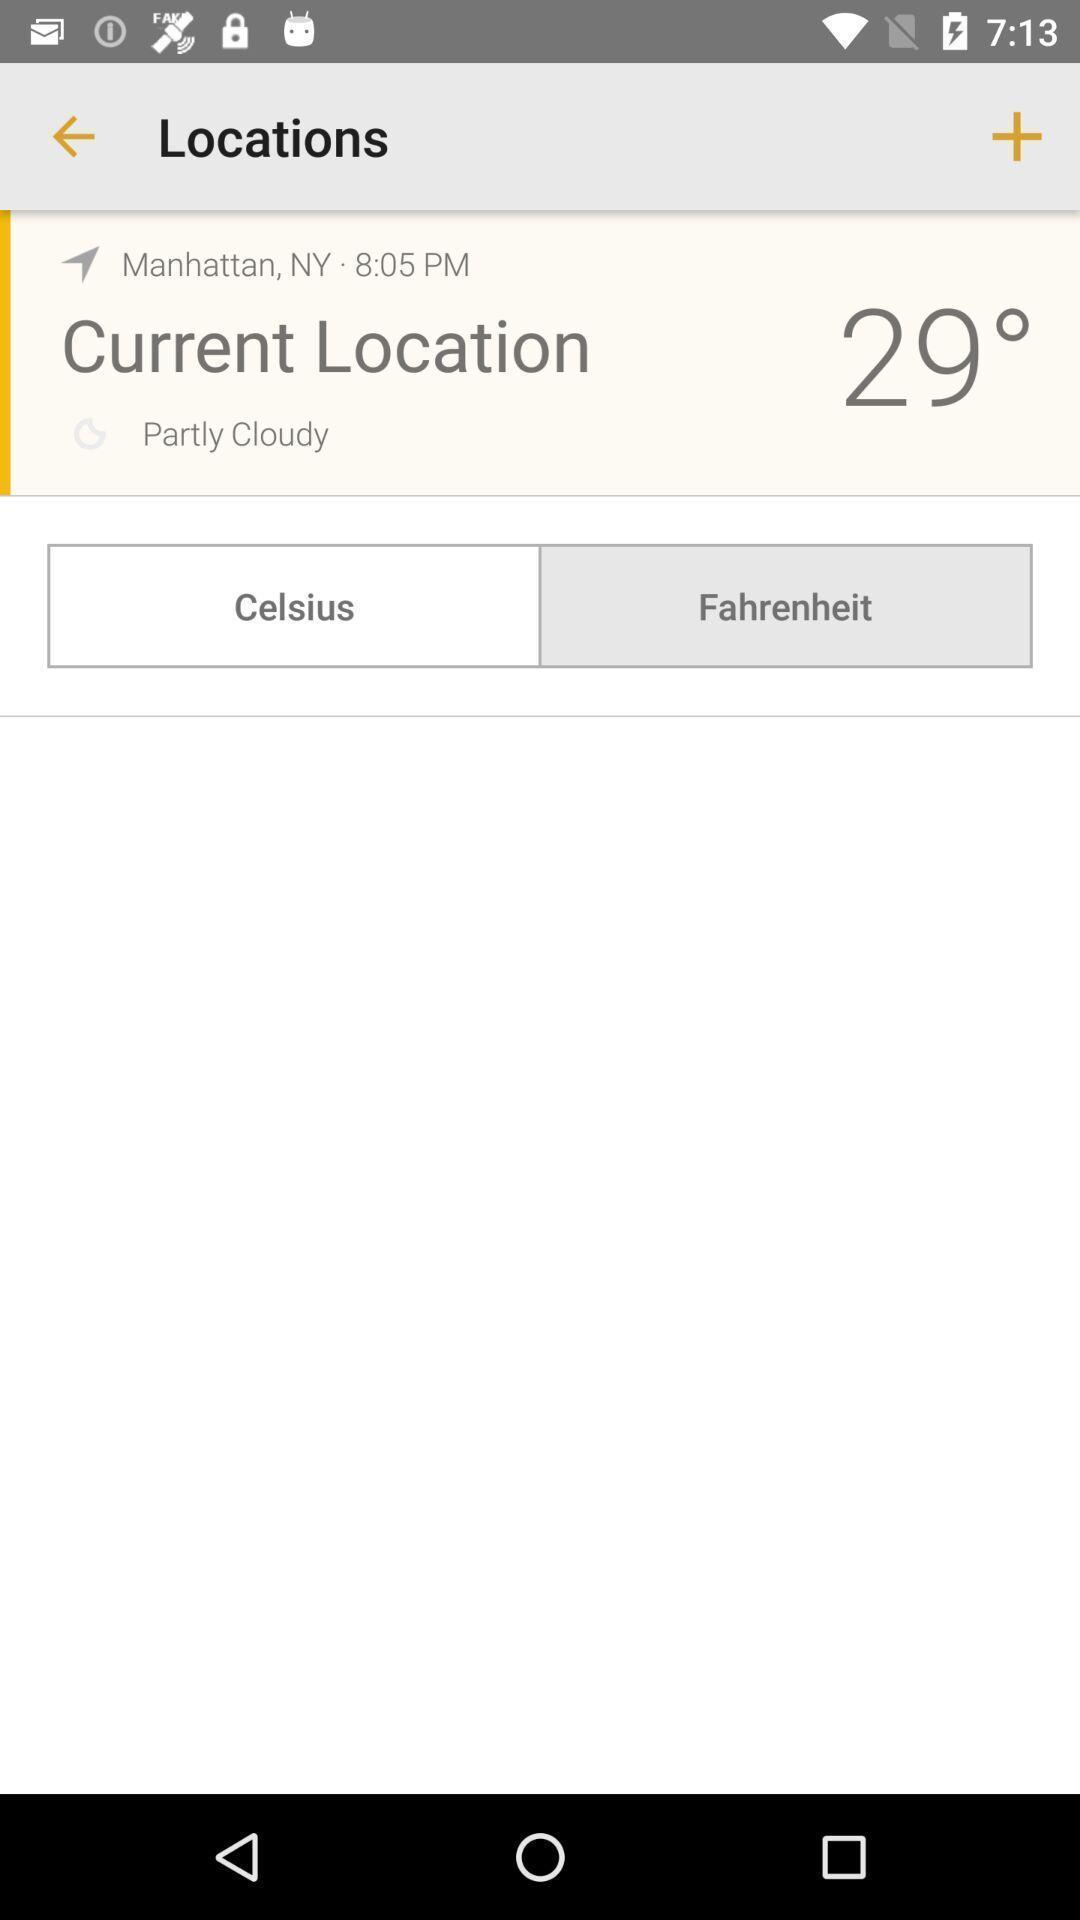Give me a narrative description of this picture. Page showing the weather report of a location. 